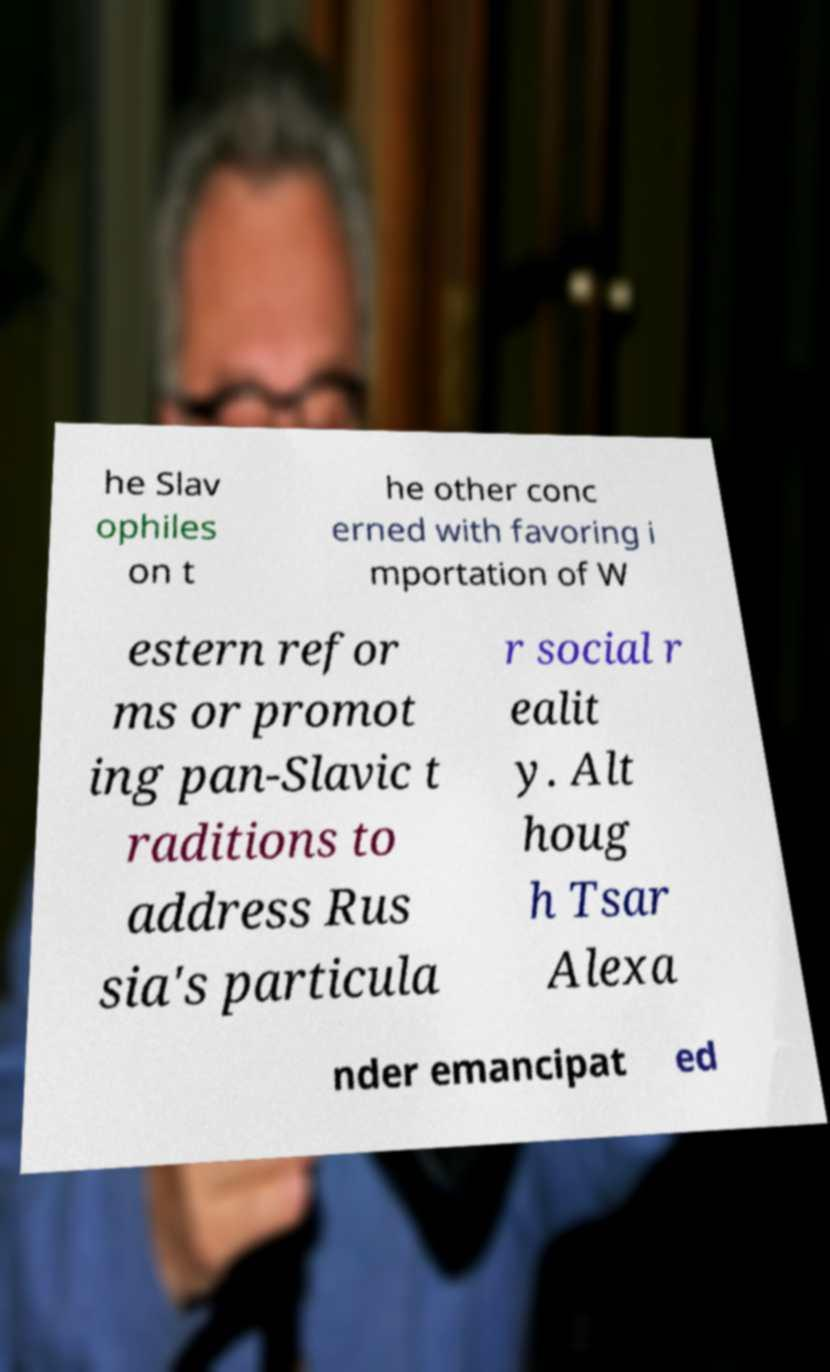There's text embedded in this image that I need extracted. Can you transcribe it verbatim? he Slav ophiles on t he other conc erned with favoring i mportation of W estern refor ms or promot ing pan-Slavic t raditions to address Rus sia's particula r social r ealit y. Alt houg h Tsar Alexa nder emancipat ed 